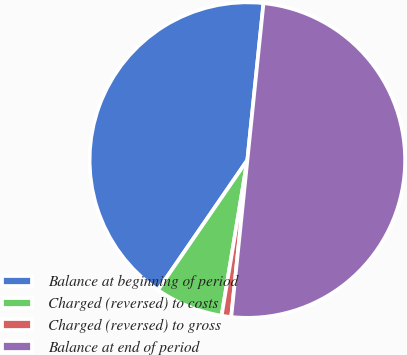Convert chart. <chart><loc_0><loc_0><loc_500><loc_500><pie_chart><fcel>Balance at beginning of period<fcel>Charged (reversed) to costs<fcel>Charged (reversed) to gross<fcel>Balance at end of period<nl><fcel>42.04%<fcel>6.98%<fcel>0.98%<fcel>50.0%<nl></chart> 